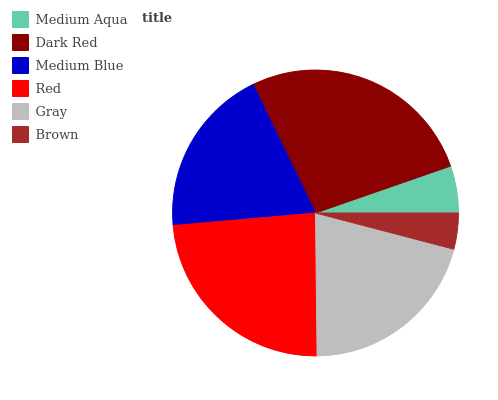Is Brown the minimum?
Answer yes or no. Yes. Is Dark Red the maximum?
Answer yes or no. Yes. Is Medium Blue the minimum?
Answer yes or no. No. Is Medium Blue the maximum?
Answer yes or no. No. Is Dark Red greater than Medium Blue?
Answer yes or no. Yes. Is Medium Blue less than Dark Red?
Answer yes or no. Yes. Is Medium Blue greater than Dark Red?
Answer yes or no. No. Is Dark Red less than Medium Blue?
Answer yes or no. No. Is Gray the high median?
Answer yes or no. Yes. Is Medium Blue the low median?
Answer yes or no. Yes. Is Medium Aqua the high median?
Answer yes or no. No. Is Gray the low median?
Answer yes or no. No. 